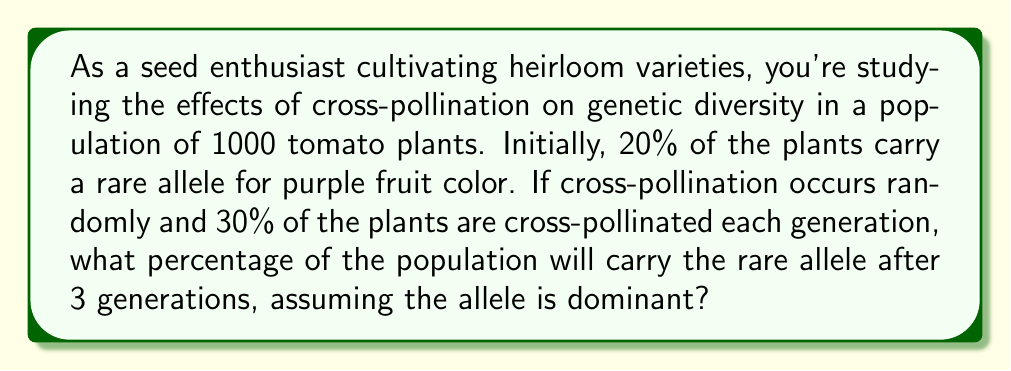Can you solve this math problem? Let's approach this step-by-step:

1) First, we need to understand what happens in each generation:
   - 70% of plants self-pollinate, maintaining their genetic makeup
   - 30% cross-pollinate randomly

2) Let $p_n$ be the proportion of plants with the rare allele in generation $n$.
   Initially, $p_0 = 0.20$ or 20%

3) In each generation, the proportion of plants with the rare allele after cross-pollination can be calculated as:

   $$p_{n+1} = 0.7p_n + 0.3(1-(1-p_n)^2)$$

   This formula comes from:
   - 70% self-pollinate: $0.7p_n$
   - 30% cross-pollinate: $0.3(1-(1-p_n)^2)$
     The $(1-p_n)^2$ term represents the probability of two plants without the allele crossing

4) Let's calculate for each generation:

   Generation 1:
   $$p_1 = 0.7(0.20) + 0.3(1-(1-0.20)^2) = 0.14 + 0.3(0.36) = 0.248$$

   Generation 2:
   $$p_2 = 0.7(0.248) + 0.3(1-(1-0.248)^2) = 0.1736 + 0.3(0.4359) = 0.3044$$

   Generation 3:
   $$p_3 = 0.7(0.3044) + 0.3(1-(1-0.3044)^2) = 0.2131 + 0.3(0.5139) = 0.3673$$

5) Convert to a percentage: $0.3673 * 100 = 36.73\%$
Answer: After 3 generations, approximately 36.73% of the tomato plant population will carry the rare allele for purple fruit color. 